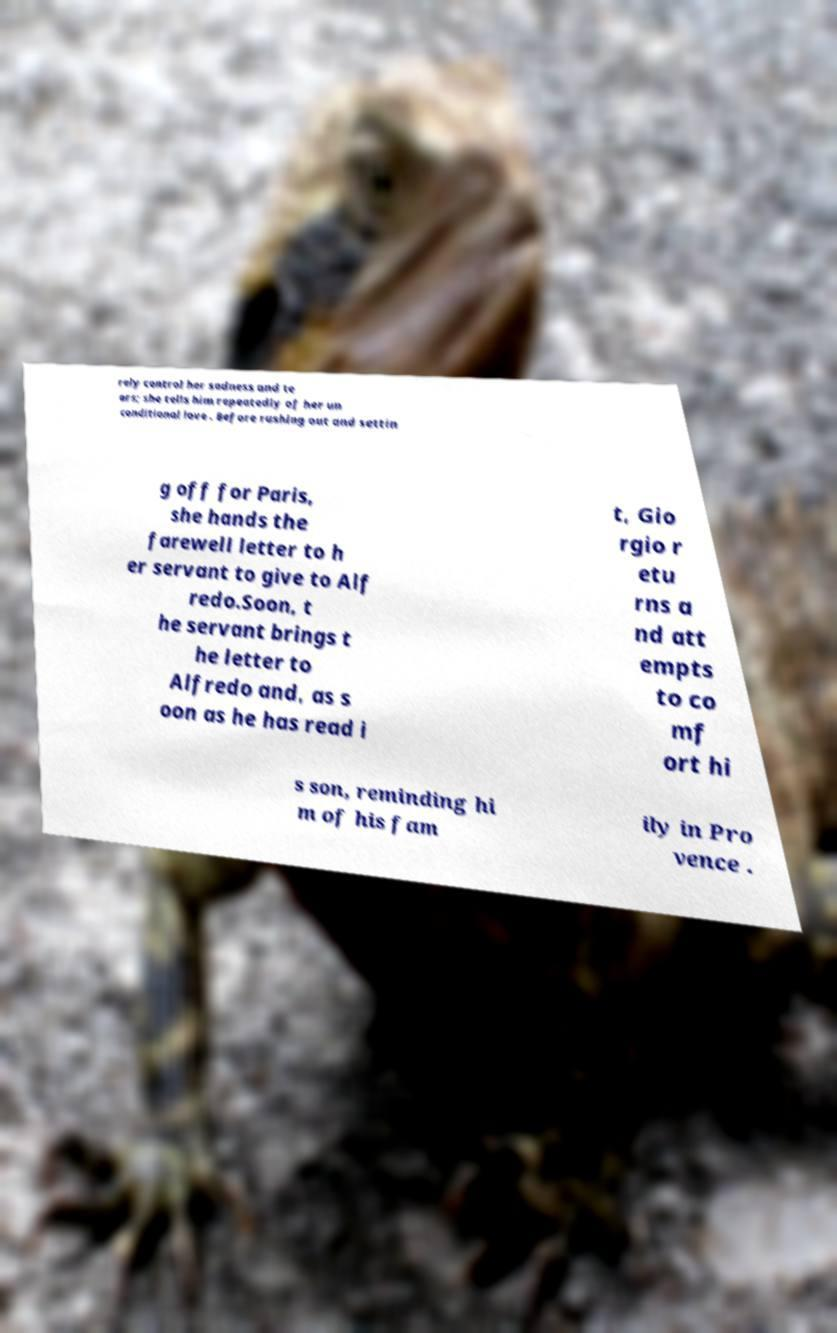Can you accurately transcribe the text from the provided image for me? rely control her sadness and te ars; she tells him repeatedly of her un conditional love . Before rushing out and settin g off for Paris, she hands the farewell letter to h er servant to give to Alf redo.Soon, t he servant brings t he letter to Alfredo and, as s oon as he has read i t, Gio rgio r etu rns a nd att empts to co mf ort hi s son, reminding hi m of his fam ily in Pro vence . 